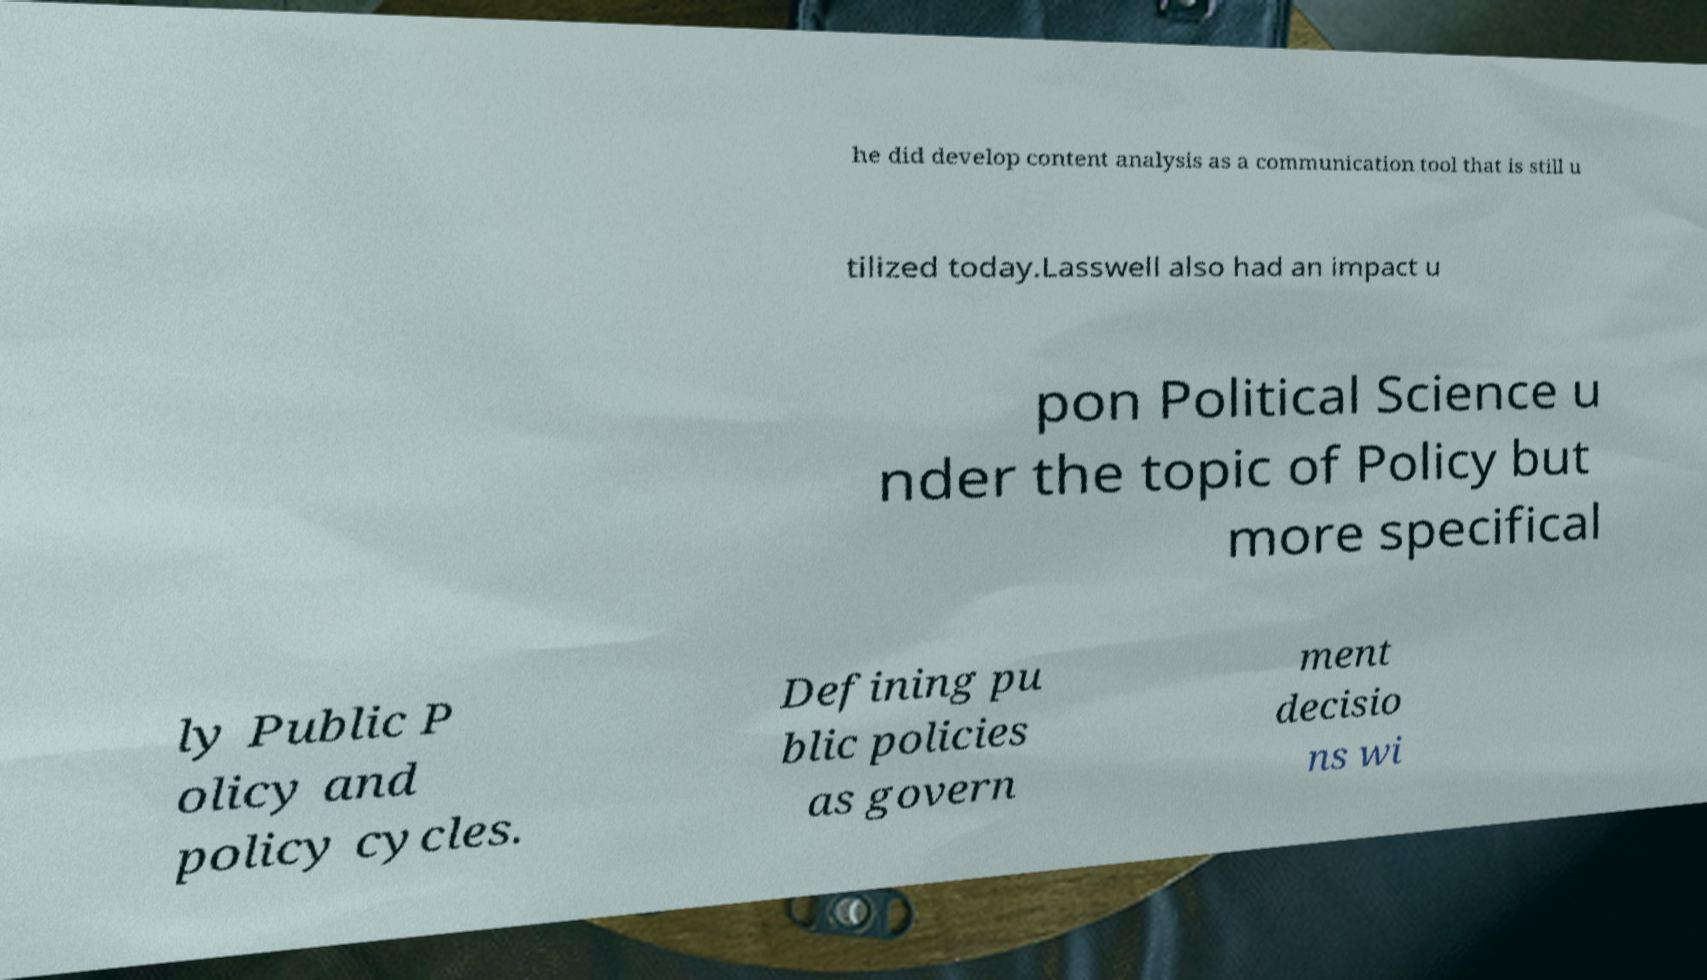Can you accurately transcribe the text from the provided image for me? he did develop content analysis as a communication tool that is still u tilized today.Lasswell also had an impact u pon Political Science u nder the topic of Policy but more specifical ly Public P olicy and policy cycles. Defining pu blic policies as govern ment decisio ns wi 